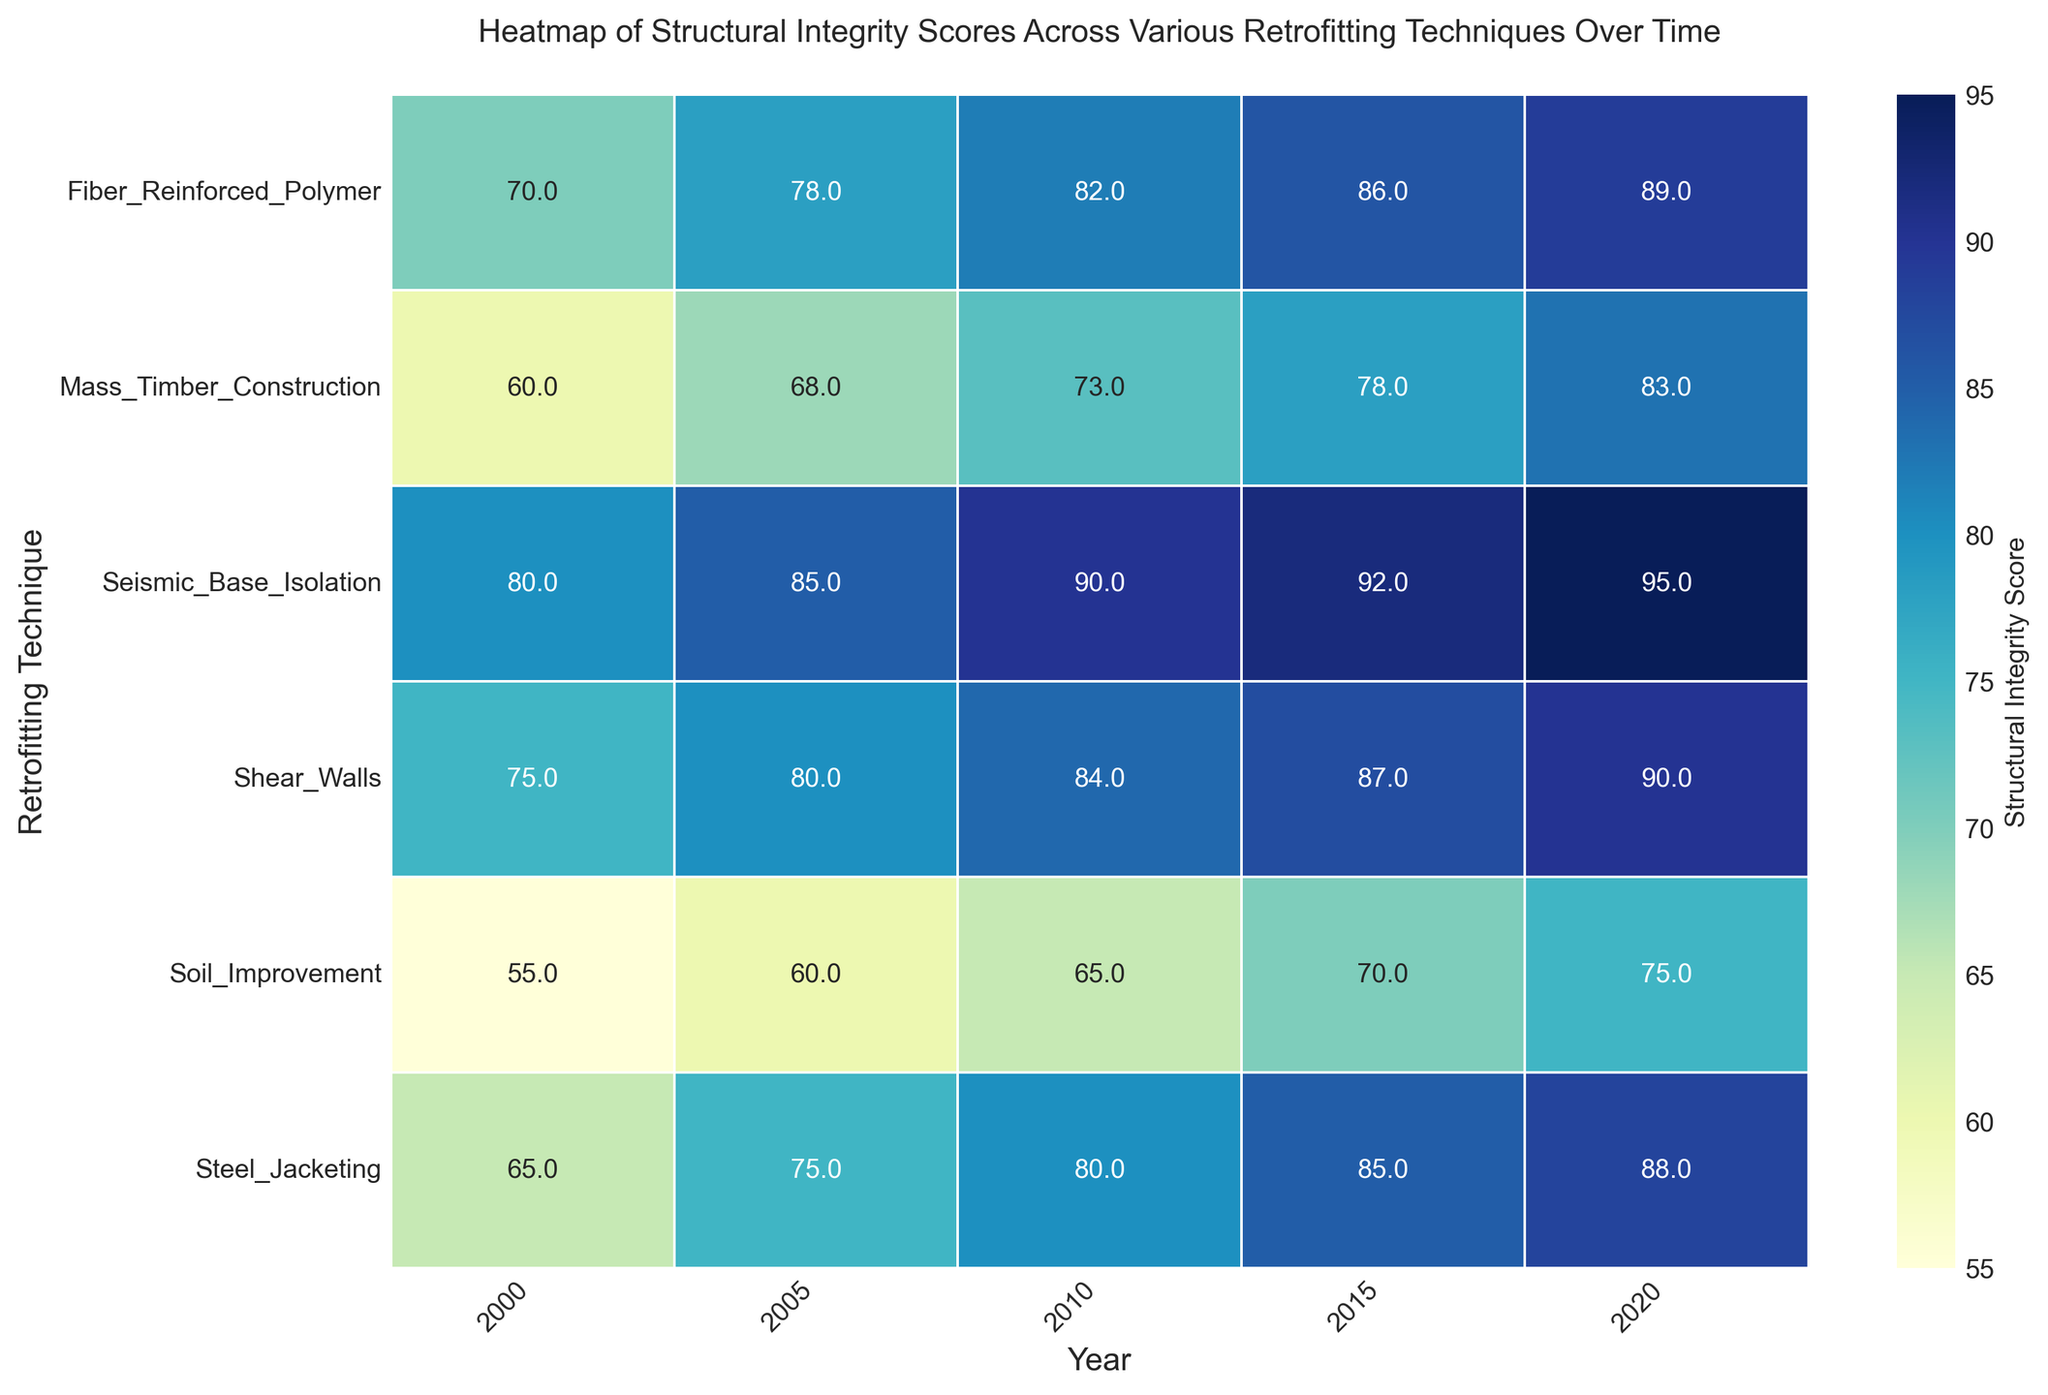Which retrofitting technique showed the highest structural integrity score in 2020? From the heatmap, observe which cell corresponds to the year 2020. Compare the structural integrity scores of all techniques for the year 2020. Seismic Base Isolation has the highest score.
Answer: Seismic Base Isolation How does the average structural integrity score of Seismic Base Isolation in 2000 and 2020 compare to the average score of Shear Walls in the same years? For Seismic Base Isolation, the scores are 80 (2000) and 95 (2020). Their average is (80+95)/2 = 87.5. For Shear Walls, the scores are 75 (2000) and 90 (2020). Their average is (75+90)/2 = 82.5. Compare the two averages. 87.5 > 82.5.
Answer: Seismic Base Isolation has a higher average score Which retrofitting technique exhibits the largest improvement in structural integrity score from 2000 to 2020? Calculate the improvement (2020 score - 2000 score) for each technique: 
- Seismic Base Isolation: 95 - 80 = 15
- Shear Walls: 90 - 75 = 15
- Fiber Reinforced Polymer: 89 - 70 = 19
- Steel Jacketing: 88 - 65 = 23
- Mass Timber Construction: 83 - 60 = 23
- Soil Improvement: 75 - 55 = 20
Steel Jacketing and Mass Timber Construction both exhibit the largest improvement.
Answer: Steel Jacketing and Mass Timber Construction Which technique exhibited the lowest structural integrity score in 2000 and what was the score? For the year 2000, observe which cell has the lowest structural integrity score and note the corresponding technique and value. Soil Improvement has the lowest score of 55.
Answer: Soil Improvement, 55 What is the median structural integrity score for Fiber Reinforced Polymer across all years shown? Collect the scores for Fiber Reinforced Polymer: [70, 78, 82, 86, 89]. To find the median, order these scores (which are already in order) and select the middle value. The middle value (third score) is 82.
Answer: 82 